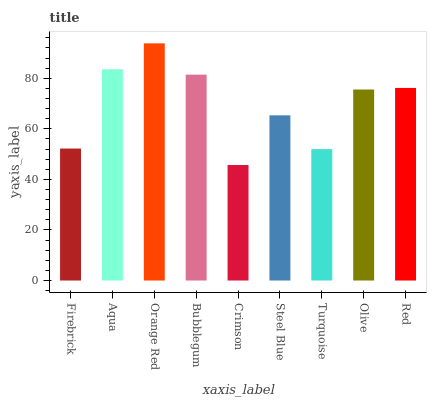Is Crimson the minimum?
Answer yes or no. Yes. Is Orange Red the maximum?
Answer yes or no. Yes. Is Aqua the minimum?
Answer yes or no. No. Is Aqua the maximum?
Answer yes or no. No. Is Aqua greater than Firebrick?
Answer yes or no. Yes. Is Firebrick less than Aqua?
Answer yes or no. Yes. Is Firebrick greater than Aqua?
Answer yes or no. No. Is Aqua less than Firebrick?
Answer yes or no. No. Is Olive the high median?
Answer yes or no. Yes. Is Olive the low median?
Answer yes or no. Yes. Is Bubblegum the high median?
Answer yes or no. No. Is Orange Red the low median?
Answer yes or no. No. 